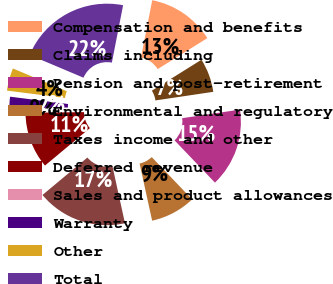<chart> <loc_0><loc_0><loc_500><loc_500><pie_chart><fcel>Compensation and benefits<fcel>Claims including<fcel>Pension and post-retirement<fcel>Environmental and regulatory<fcel>Taxes income and other<fcel>Deferred revenue<fcel>Sales and product allowances<fcel>Warranty<fcel>Other<fcel>Total<nl><fcel>13.04%<fcel>6.53%<fcel>15.21%<fcel>8.7%<fcel>17.38%<fcel>10.87%<fcel>0.01%<fcel>2.18%<fcel>4.36%<fcel>21.72%<nl></chart> 